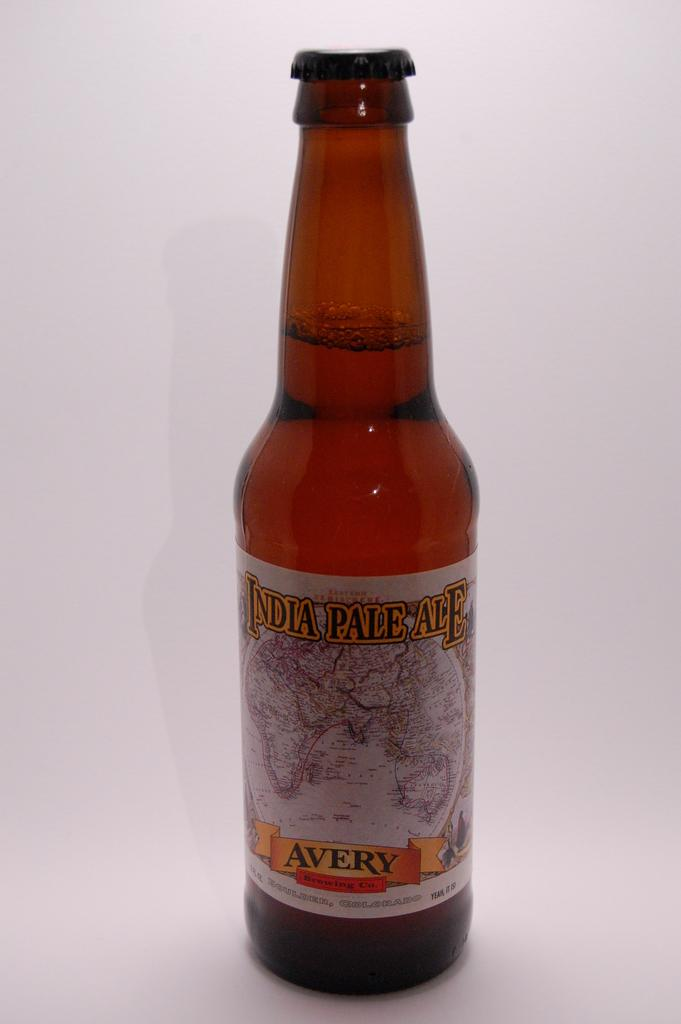<image>
Provide a brief description of the given image. A bottle of India Pale Ale on a white background. 